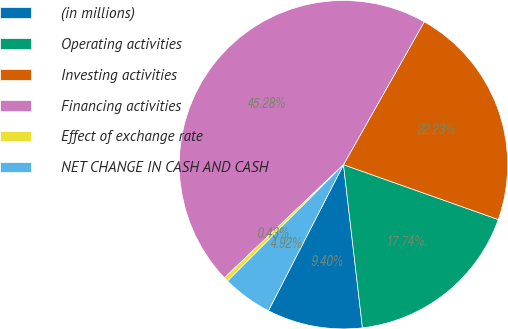Convert chart to OTSL. <chart><loc_0><loc_0><loc_500><loc_500><pie_chart><fcel>(in millions)<fcel>Operating activities<fcel>Investing activities<fcel>Financing activities<fcel>Effect of exchange rate<fcel>NET CHANGE IN CASH AND CASH<nl><fcel>9.4%<fcel>17.74%<fcel>22.23%<fcel>45.28%<fcel>0.43%<fcel>4.92%<nl></chart> 